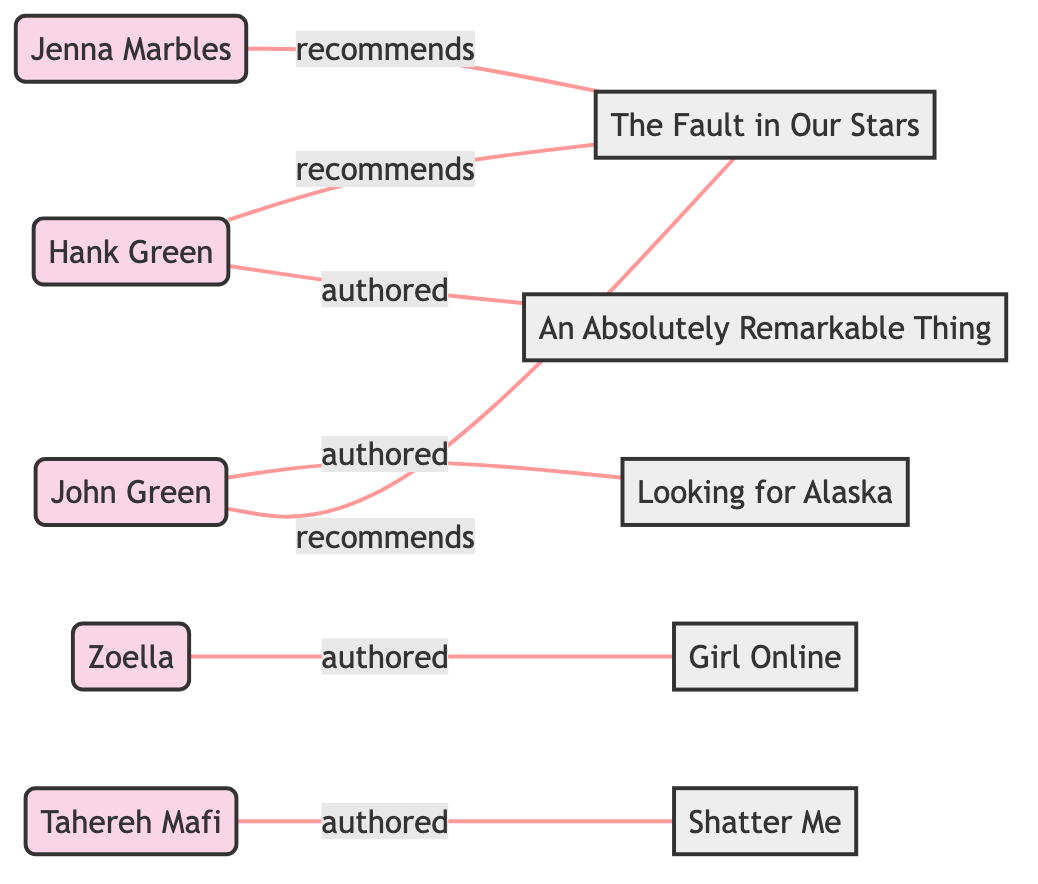What is the total number of influencers in the diagram? There are five influencers listed as nodes in the diagram: John Green, Zoella, Tahereh Mafi, Jenna Marbles, and Hank Green.
Answer: 5 Which book is recommended by both John Green and Jenna Marbles? Both influencers have a recommending relationship with "The Fault in Our Stars," indicated by edges connecting each influencer to the book node.
Answer: The Fault in Our Stars How many books are authored by influencers? The diagram shows three books authored by influencers: "Looking for Alaska" by John Green, "Girl Online" by Zoella, and "Shatter Me" by Tahereh Mafi, leading to a total of three edges labeled as "authored."
Answer: 3 Which influencer has the most recommendations? By checking the edges, we see that John Green and Hank Green both recommend "The Fault in Our Stars," but John Green is mentioned twice for two different edges: once for recommending and once for authoring a book; however, this does not pertain to recommendations as none others have multiple recommendations. Hence, Hank Green is the only one with two recommendation edges to the same book.
Answer: Hank Green What is the relationship between Tahereh Mafi and the book "Shatter Me"? In the diagram, the influence of Tahereh Mafi on "Shatter Me" is characterized as "authored," meaning she is the writer of this book as indicated by the directed edge.
Answer: authored 